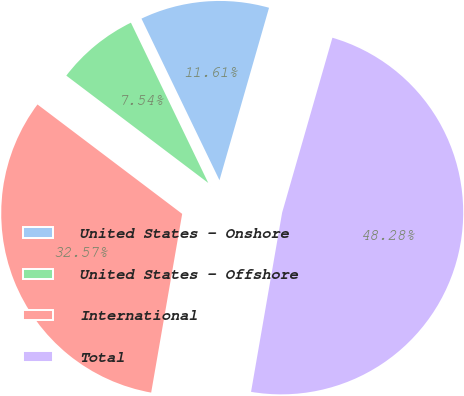Convert chart. <chart><loc_0><loc_0><loc_500><loc_500><pie_chart><fcel>United States - Onshore<fcel>United States - Offshore<fcel>International<fcel>Total<nl><fcel>11.61%<fcel>7.54%<fcel>32.57%<fcel>48.28%<nl></chart> 